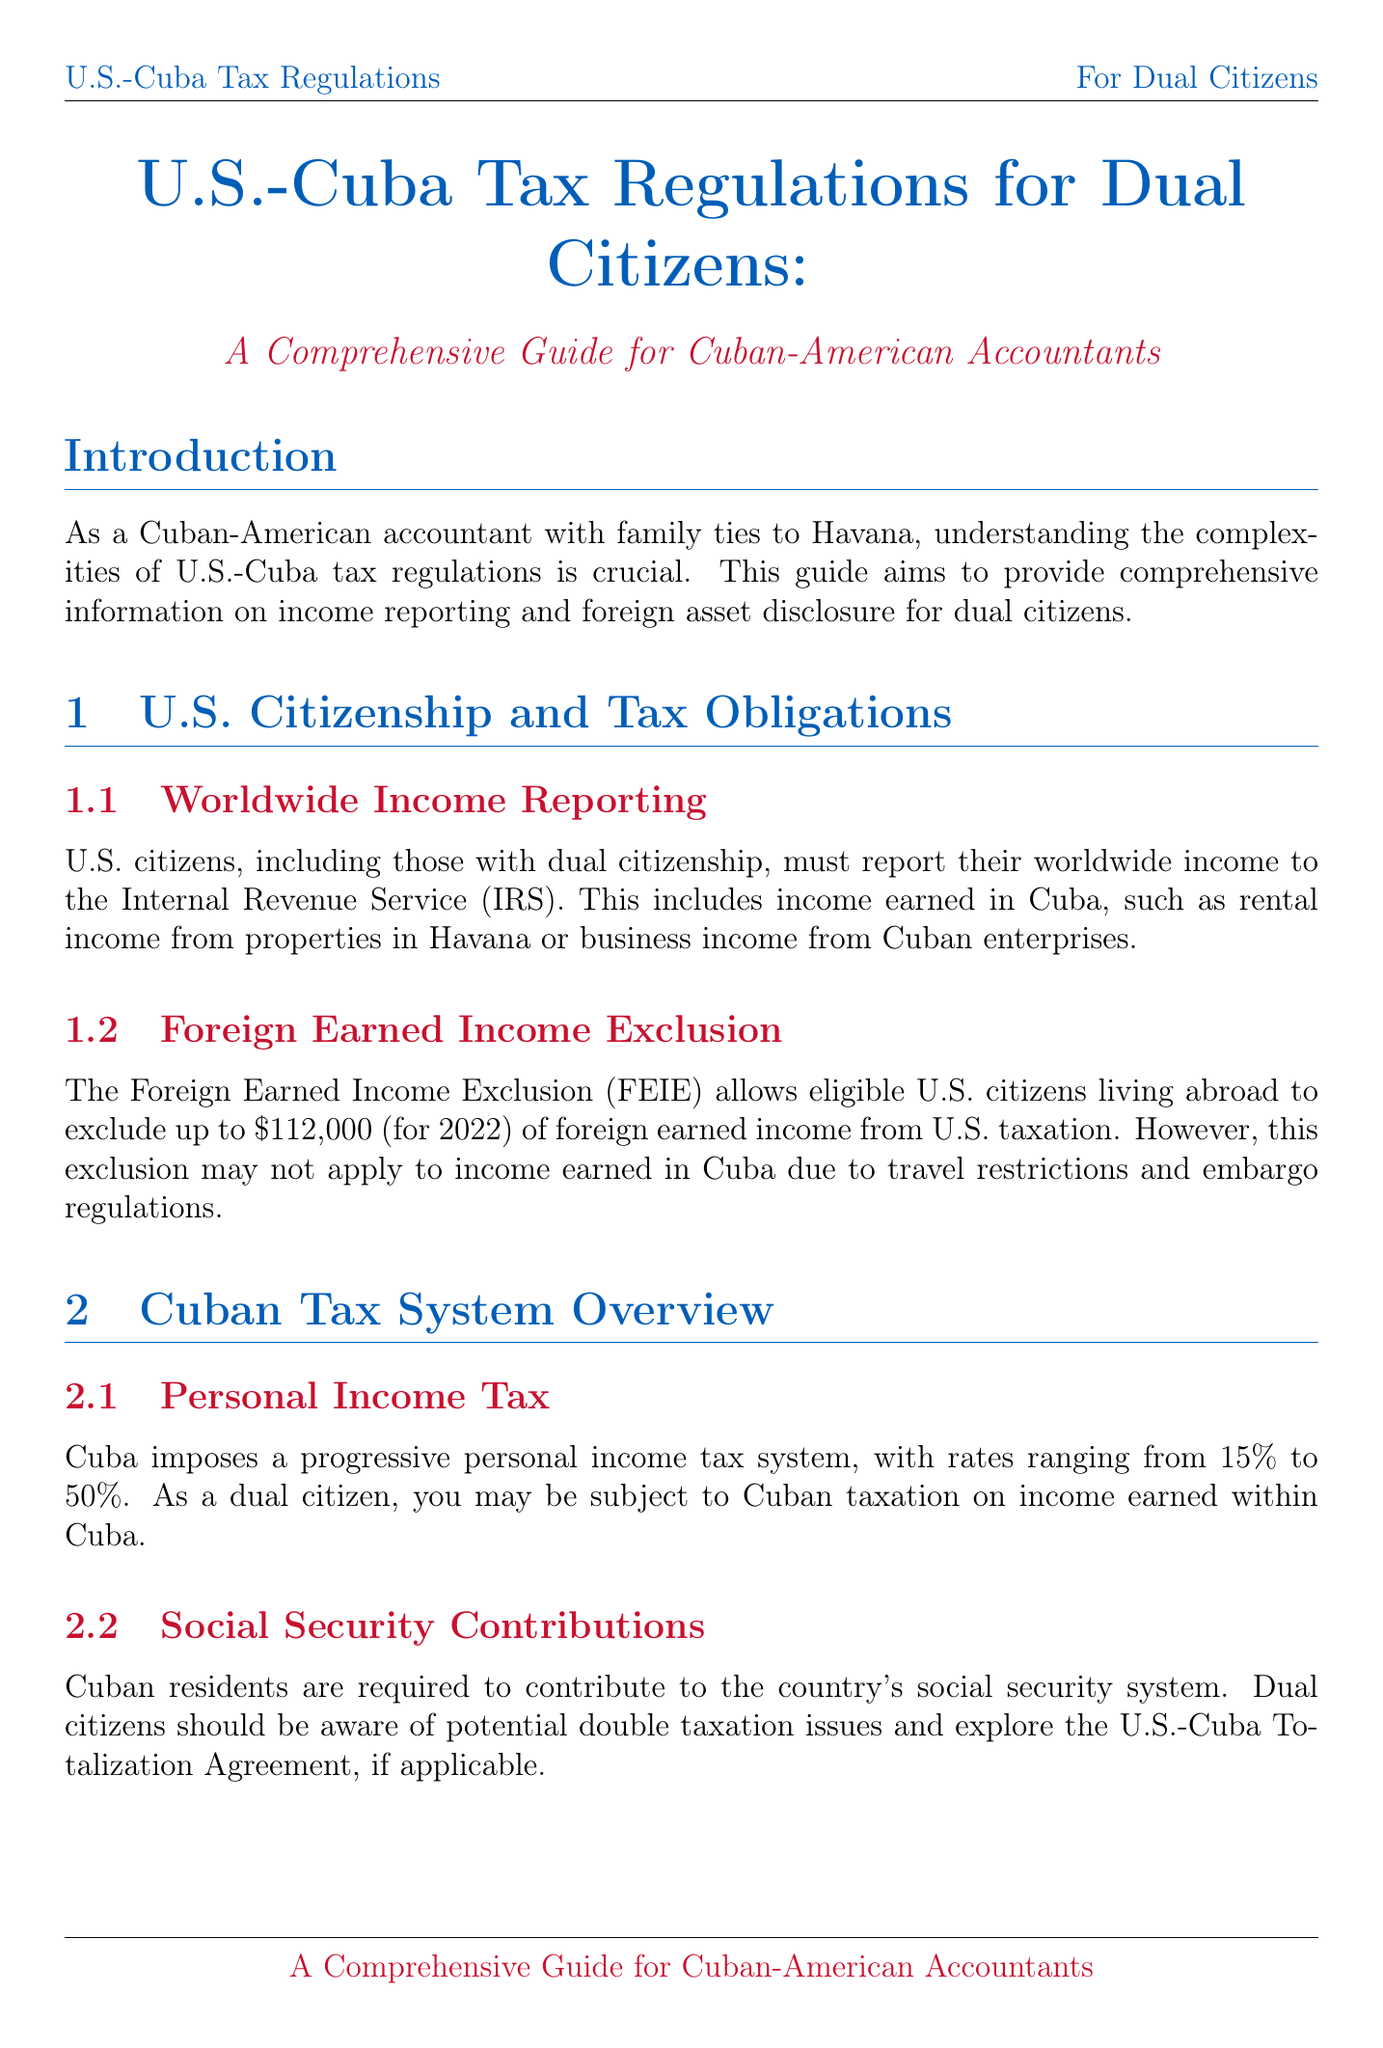what is the title of the manual? The title is clearly stated at the beginning of the document, focusing on tax regulations for dual citizens.
Answer: U.S.-Cuba Tax Regulations for Dual Citizens: A Comprehensive Guide for Cuban-American Accountants what is the foreign earned income exclusion limit for 2022? The document specifies the limit for the Foreign Earned Income Exclusion relevant for 2022.
Answer: $112,000 what percentage range does Cuba’s personal income tax cover? The document outlines the progressive tax rate for personal income in Cuba.
Answer: 15% to 50% what is the deadline for filing the FBAR? The compliance section highlights important filing deadlines, including FBAR submission.
Answer: June 30 which form is needed to report foreign financial accounts? The document indicates specific reporting requirements for foreign financial accounts.
Answer: FBAR does the U.S. have a comprehensive tax treaty with Cuba? The manual addresses the current relationship in terms of tax treaties between the two countries.
Answer: No what should dual citizens consider to avoid double taxation? The section on tax planning strategies discusses methods to mitigate double taxation.
Answer: Foreign Tax Credits what is the total taxation rate system in Cuba for personal income? The Cuban tax system overview provides insight into how personal income tax is structured.
Answer: progressive personal income tax system which forms are needed for reporting Cuban business ownership? The document lists the forms relevant to dual citizens with Cuban business interests.
Answer: Form 5471 and Form 8858 